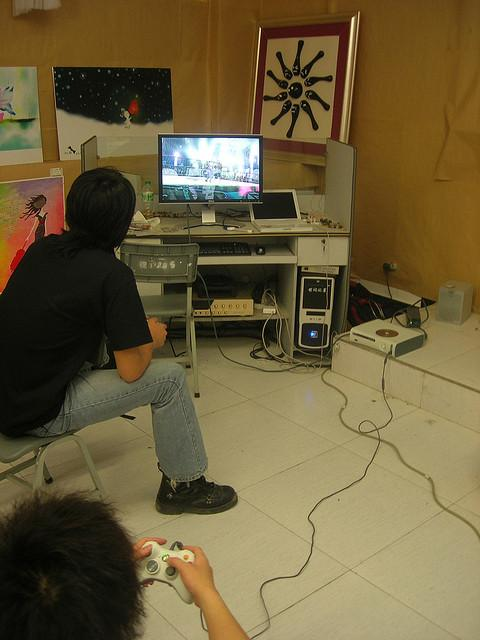What are the people playing? video game 